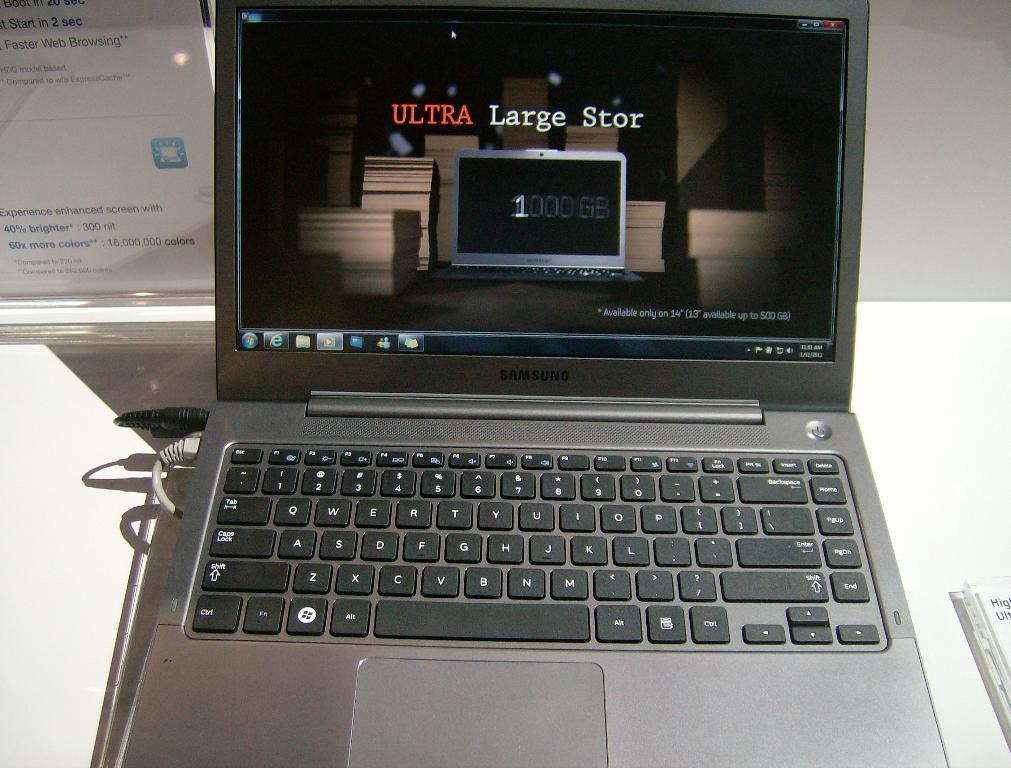<image>
Relay a brief, clear account of the picture shown. A Laptop computer made by Samsung displays an advertisement for another computer package. 